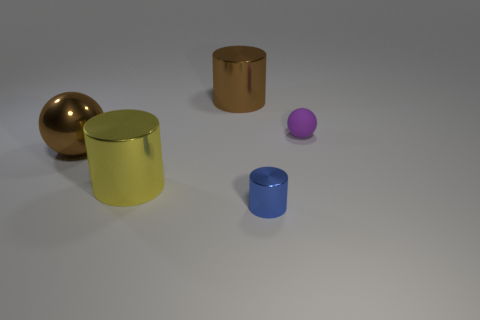What shape is the blue shiny thing that is the same size as the purple ball?
Provide a succinct answer. Cylinder. Is there a big yellow metal object that has the same shape as the blue metallic thing?
Offer a terse response. Yes. Is the material of the tiny cylinder the same as the small object behind the blue object?
Offer a terse response. No. There is a cylinder that is to the right of the cylinder that is behind the big brown thing in front of the big brown shiny cylinder; what is its color?
Keep it short and to the point. Blue. There is a object that is the same size as the blue metal cylinder; what material is it?
Offer a very short reply. Rubber. How many small objects have the same material as the big brown cylinder?
Your answer should be compact. 1. There is a sphere on the right side of the big sphere; does it have the same size as the ball that is to the left of the tiny blue shiny object?
Offer a terse response. No. There is a shiny sphere in front of the small purple object; what color is it?
Offer a terse response. Brown. There is a big object that is the same color as the metal ball; what is it made of?
Your answer should be compact. Metal. What number of metallic cylinders have the same color as the shiny ball?
Give a very brief answer. 1. 